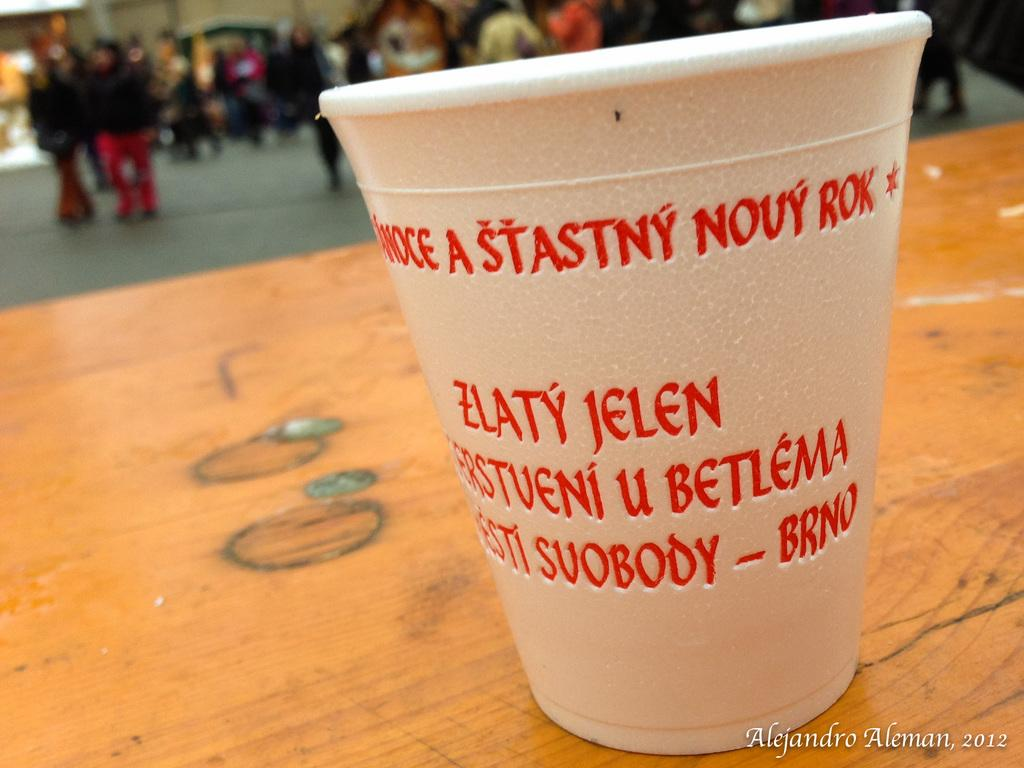What object is placed on the table in the image? There is a glass placed on a table in the image. What can be seen in the background of the image? People are walking on the surface of a road in the background of the image. What type of cushion is placed on the glass in the image? There is no cushion present on the glass in the image. Can you describe the owl sitting on the table next to the glass? There is no owl present in the image; it only features a glass placed on a table and people walking in the background. 